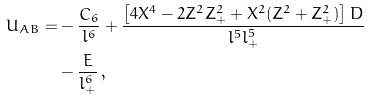Convert formula to latex. <formula><loc_0><loc_0><loc_500><loc_500>U _ { A B } = & - \frac { C _ { 6 } } { l ^ { 6 } } + \frac { \left [ 4 X ^ { 4 } - 2 Z ^ { 2 } Z _ { + } ^ { 2 } + X ^ { 2 } ( Z ^ { 2 } + Z _ { + } ^ { 2 } ) \right ] D } { l ^ { 5 } l _ { + } ^ { 5 } } \\ & - \frac { E } { l _ { + } ^ { 6 } } \, ,</formula> 